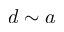Convert formula to latex. <formula><loc_0><loc_0><loc_500><loc_500>d \sim a</formula> 